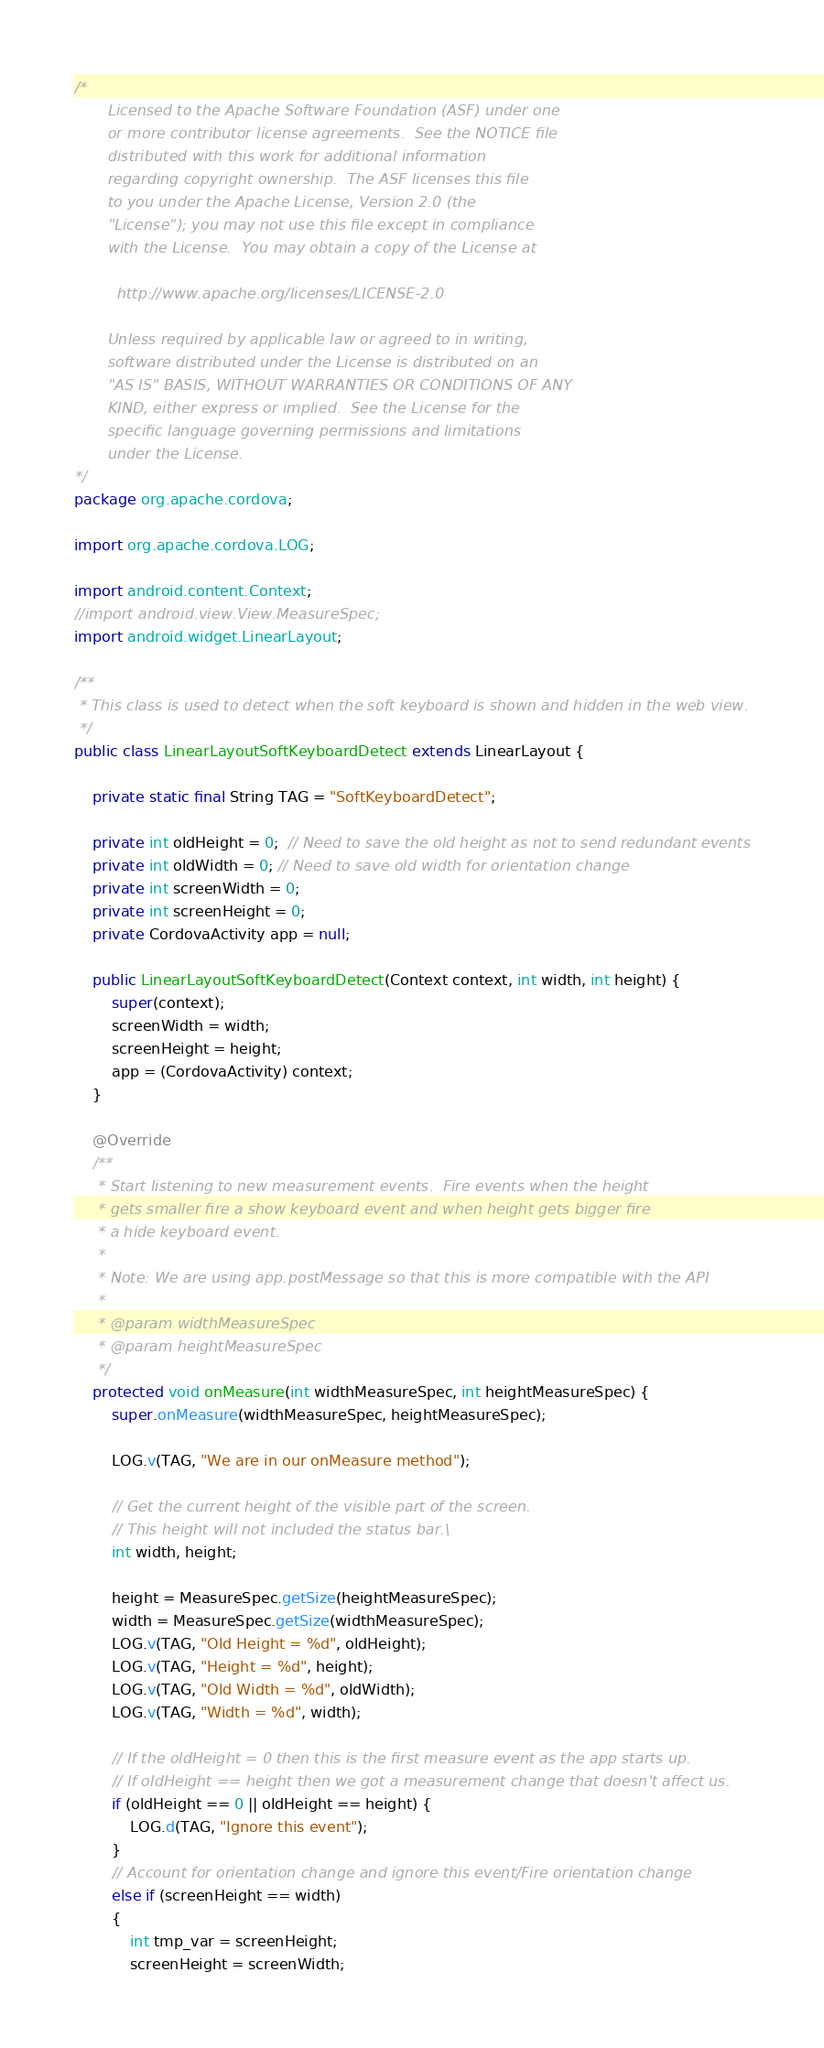Convert code to text. <code><loc_0><loc_0><loc_500><loc_500><_Java_>/*
       Licensed to the Apache Software Foundation (ASF) under one
       or more contributor license agreements.  See the NOTICE file
       distributed with this work for additional information
       regarding copyright ownership.  The ASF licenses this file
       to you under the Apache License, Version 2.0 (the
       "License"); you may not use this file except in compliance
       with the License.  You may obtain a copy of the License at

         http://www.apache.org/licenses/LICENSE-2.0

       Unless required by applicable law or agreed to in writing,
       software distributed under the License is distributed on an
       "AS IS" BASIS, WITHOUT WARRANTIES OR CONDITIONS OF ANY
       KIND, either express or implied.  See the License for the
       specific language governing permissions and limitations
       under the License.
*/
package org.apache.cordova;

import org.apache.cordova.LOG;

import android.content.Context;
//import android.view.View.MeasureSpec;
import android.widget.LinearLayout;

/**
 * This class is used to detect when the soft keyboard is shown and hidden in the web view.
 */
public class LinearLayoutSoftKeyboardDetect extends LinearLayout {

    private static final String TAG = "SoftKeyboardDetect";

    private int oldHeight = 0;  // Need to save the old height as not to send redundant events
    private int oldWidth = 0; // Need to save old width for orientation change
    private int screenWidth = 0;
    private int screenHeight = 0;
    private CordovaActivity app = null;

    public LinearLayoutSoftKeyboardDetect(Context context, int width, int height) {
        super(context);
        screenWidth = width;
        screenHeight = height;
        app = (CordovaActivity) context;
    }

    @Override
    /**
     * Start listening to new measurement events.  Fire events when the height
     * gets smaller fire a show keyboard event and when height gets bigger fire
     * a hide keyboard event.
     *
     * Note: We are using app.postMessage so that this is more compatible with the API
     *
     * @param widthMeasureSpec
     * @param heightMeasureSpec
     */
    protected void onMeasure(int widthMeasureSpec, int heightMeasureSpec) {
        super.onMeasure(widthMeasureSpec, heightMeasureSpec);

        LOG.v(TAG, "We are in our onMeasure method");

        // Get the current height of the visible part of the screen.
        // This height will not included the status bar.\
        int width, height;

        height = MeasureSpec.getSize(heightMeasureSpec);
        width = MeasureSpec.getSize(widthMeasureSpec);
        LOG.v(TAG, "Old Height = %d", oldHeight);
        LOG.v(TAG, "Height = %d", height);
        LOG.v(TAG, "Old Width = %d", oldWidth);
        LOG.v(TAG, "Width = %d", width);

        // If the oldHeight = 0 then this is the first measure event as the app starts up.
        // If oldHeight == height then we got a measurement change that doesn't affect us.
        if (oldHeight == 0 || oldHeight == height) {
            LOG.d(TAG, "Ignore this event");
        }
        // Account for orientation change and ignore this event/Fire orientation change
        else if (screenHeight == width)
        {
            int tmp_var = screenHeight;
            screenHeight = screenWidth;</code> 